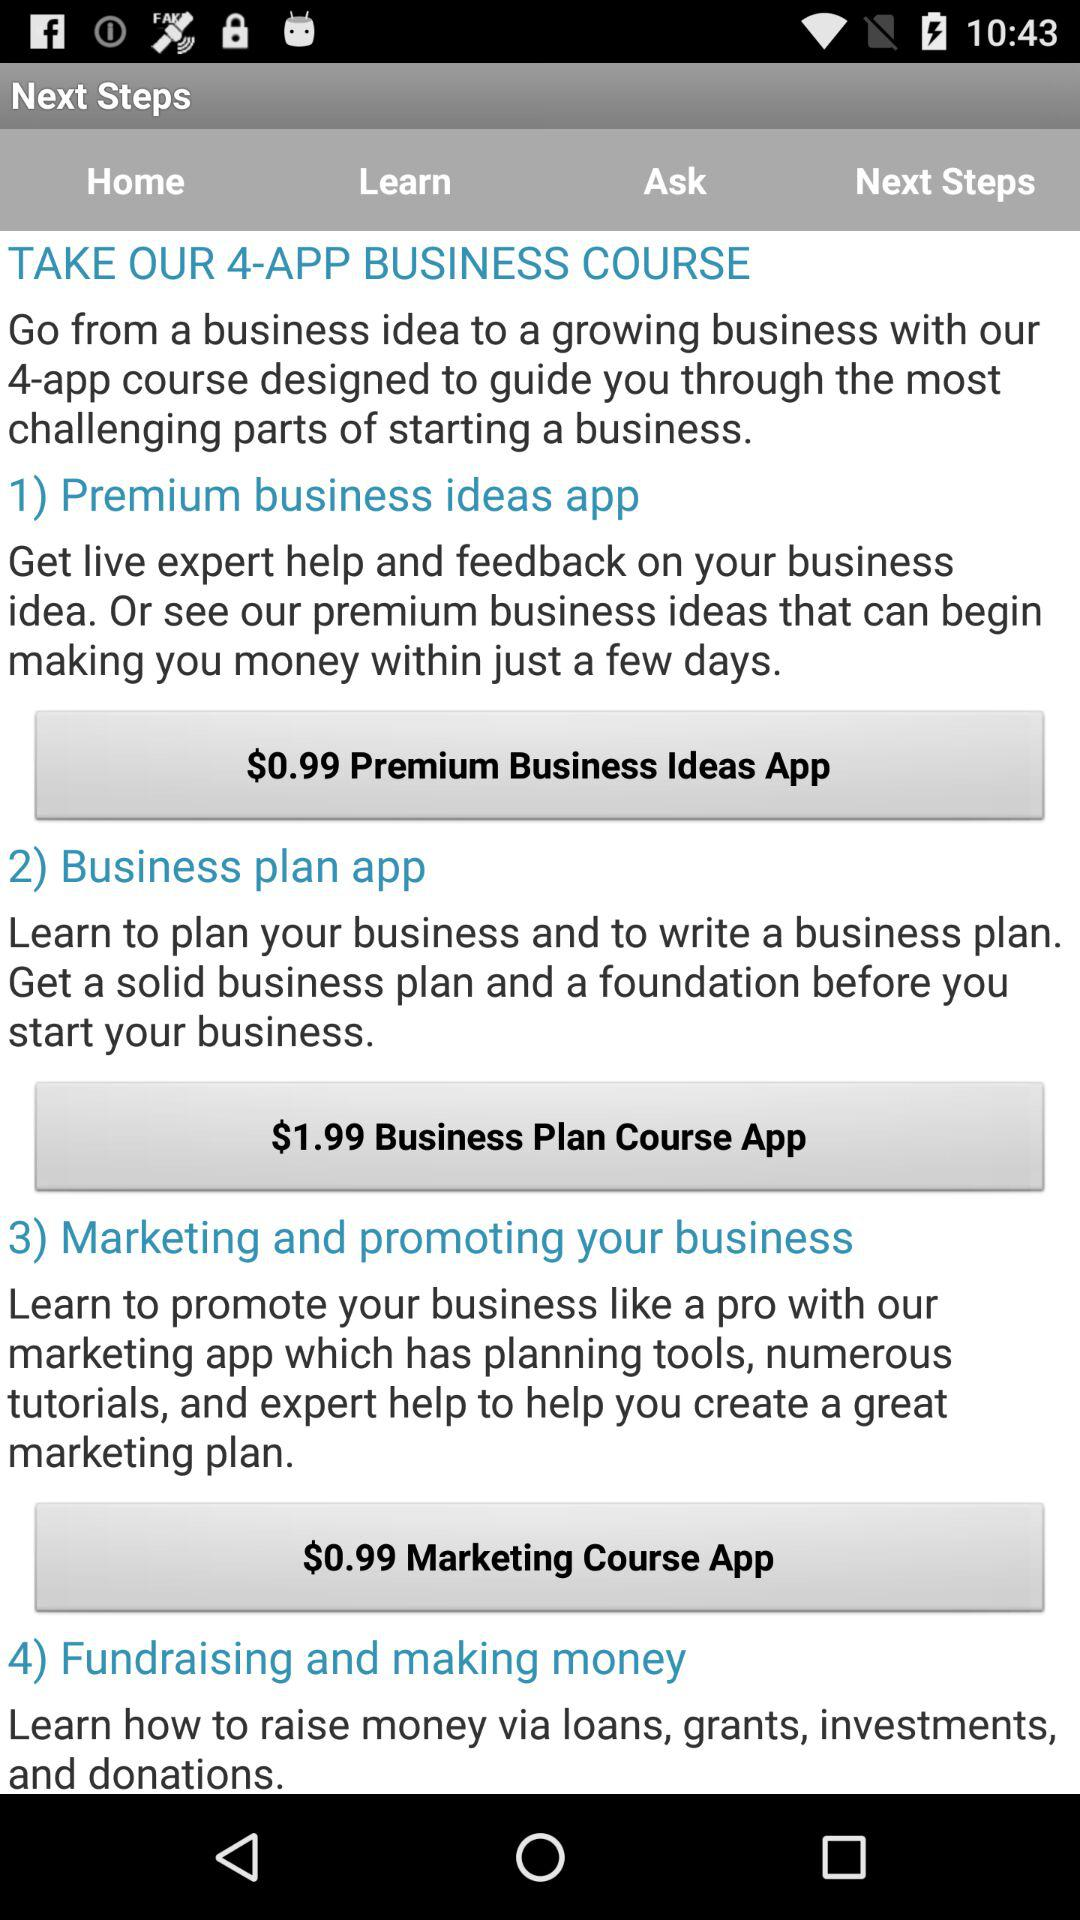What is the price of the "Business Plan Course App"? The price of the "Business Plan Course App" is $1.99. 